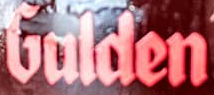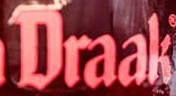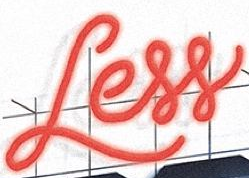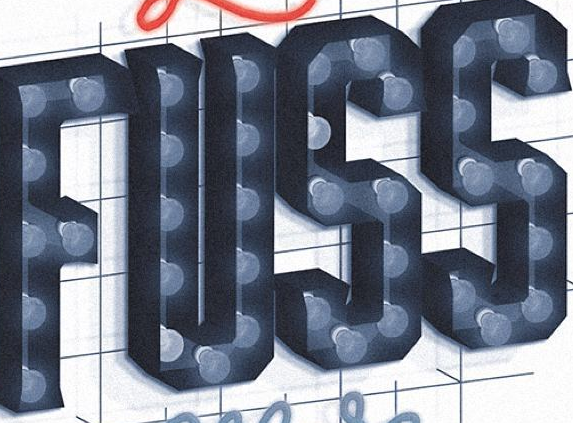What words are shown in these images in order, separated by a semicolon? Gulden; Draak; Less; FUSS 